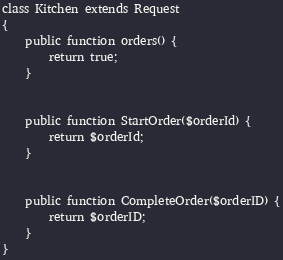<code> <loc_0><loc_0><loc_500><loc_500><_PHP_>class Kitchen extends Request
{
    public function orders() {
        return true;
    }


    public function StartOrder($orderId) {
        return $orderId;
    }


    public function CompleteOrder($orderID) {
        return $orderID;
    }
}</code> 